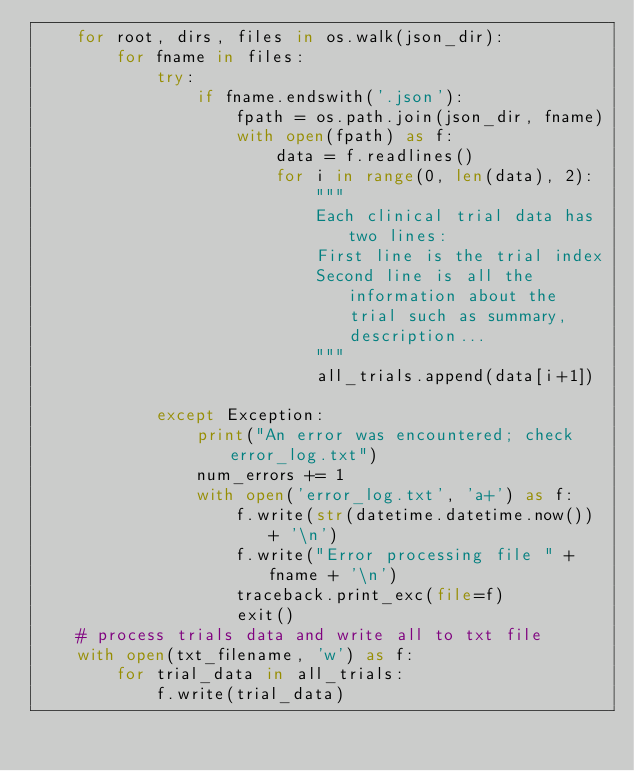<code> <loc_0><loc_0><loc_500><loc_500><_Python_>    for root, dirs, files in os.walk(json_dir):
        for fname in files:
            try:
                if fname.endswith('.json'):
                    fpath = os.path.join(json_dir, fname)
                    with open(fpath) as f:
                        data = f.readlines()
                        for i in range(0, len(data), 2):
                            """
                            Each clinical trial data has two lines:
                            First line is the trial index
                            Second line is all the information about the trial such as summary, description...
                            """
                            all_trials.append(data[i+1])

            except Exception:
                print("An error was encountered; check error_log.txt")
                num_errors += 1
                with open('error_log.txt', 'a+') as f:
                    f.write(str(datetime.datetime.now()) + '\n')
                    f.write("Error processing file " + fname + '\n')
                    traceback.print_exc(file=f)
                    exit()
    # process trials data and write all to txt file
    with open(txt_filename, 'w') as f:
        for trial_data in all_trials:
            f.write(trial_data)</code> 